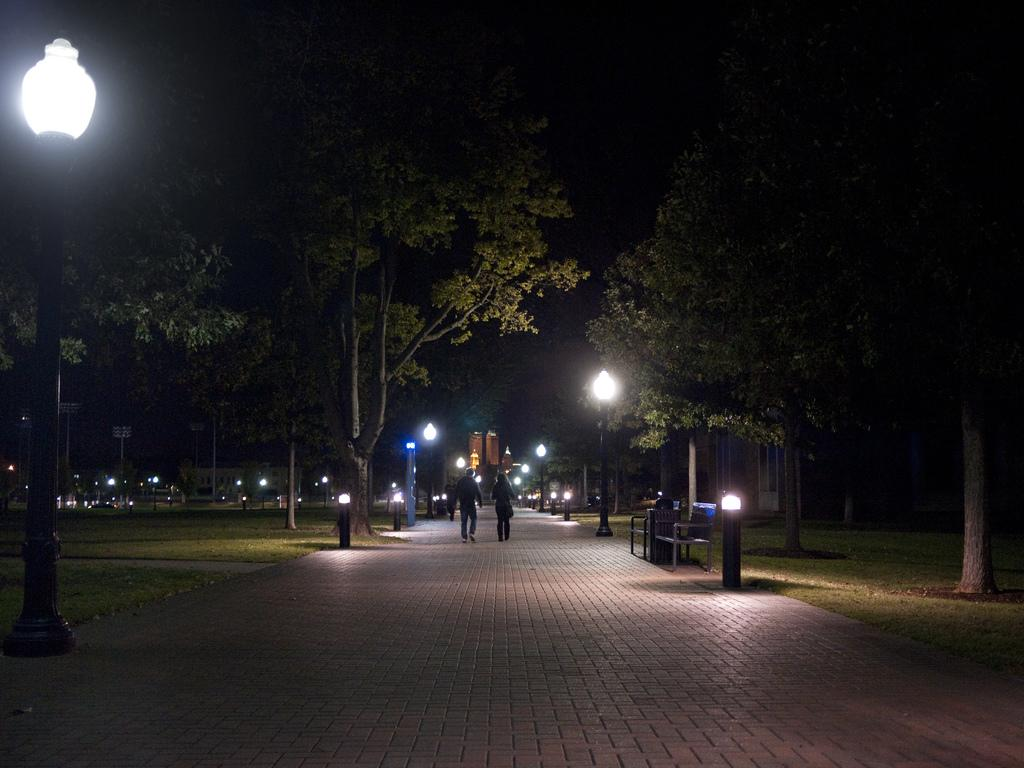What type of lighting is present in the image? There are street lamps in the image. What type of vegetation can be seen in the image? There is grass and trees in the image. What are the two people in the image doing? Two people are walking in the image. What type of structures are visible in the image? There are houses in the image. How would you describe the lighting in the image? The image is slightly dark. What type of spy equipment can be seen in the image? There is no spy equipment present in the image. What type of trade is being conducted in the image? There is no trade being conducted in the image. What type of competition is taking place in the image? There is no competition taking place in the image. 